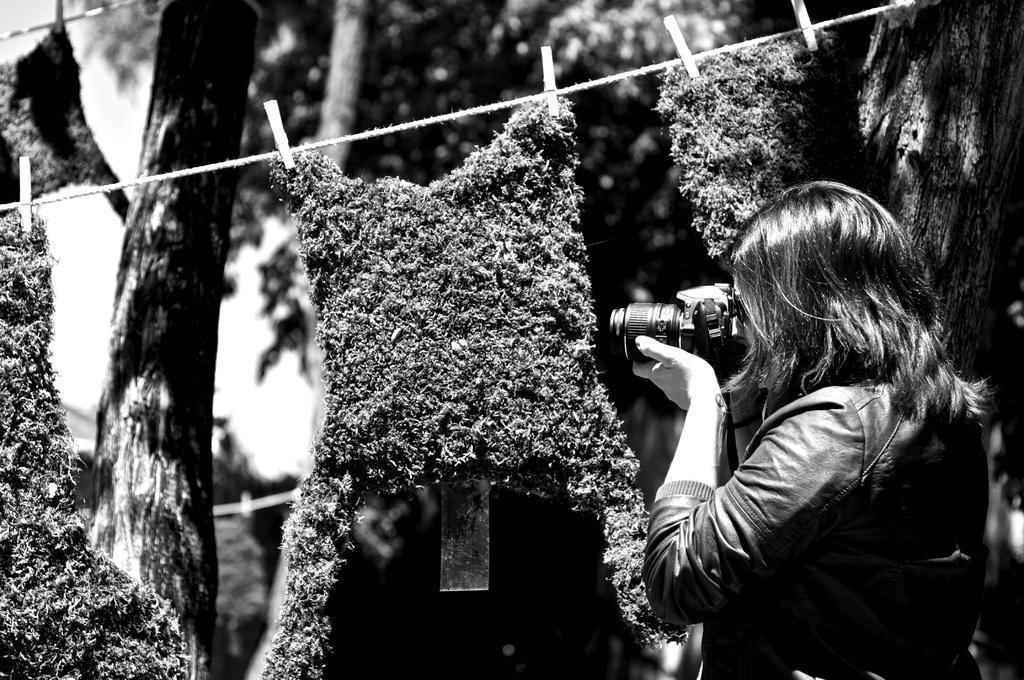In one or two sentences, can you explain what this image depicts? In this image we can see a black and white image. In this image there is a person, camera, rope and other objects. In the background of the image there are trees and the sky. 